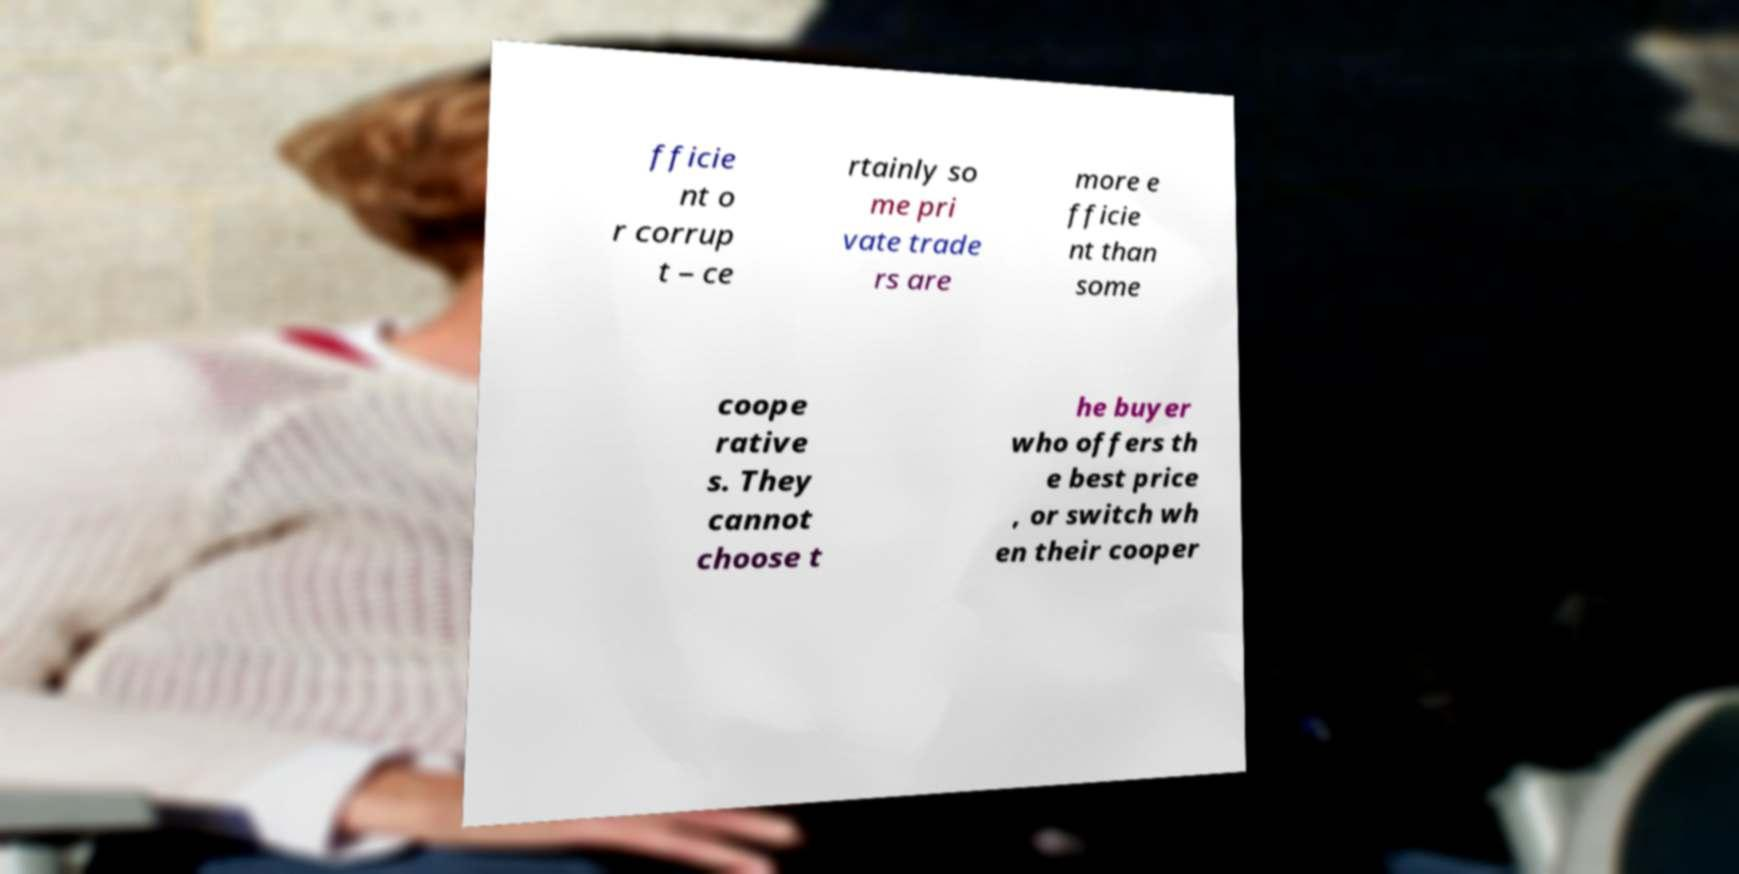What messages or text are displayed in this image? I need them in a readable, typed format. fficie nt o r corrup t – ce rtainly so me pri vate trade rs are more e fficie nt than some coope rative s. They cannot choose t he buyer who offers th e best price , or switch wh en their cooper 